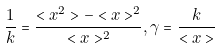<formula> <loc_0><loc_0><loc_500><loc_500>\frac { 1 } { k } = \frac { < x ^ { 2 } > - < x > ^ { 2 } } { < x > ^ { 2 } } , \gamma = \frac { k } { < x > }</formula> 